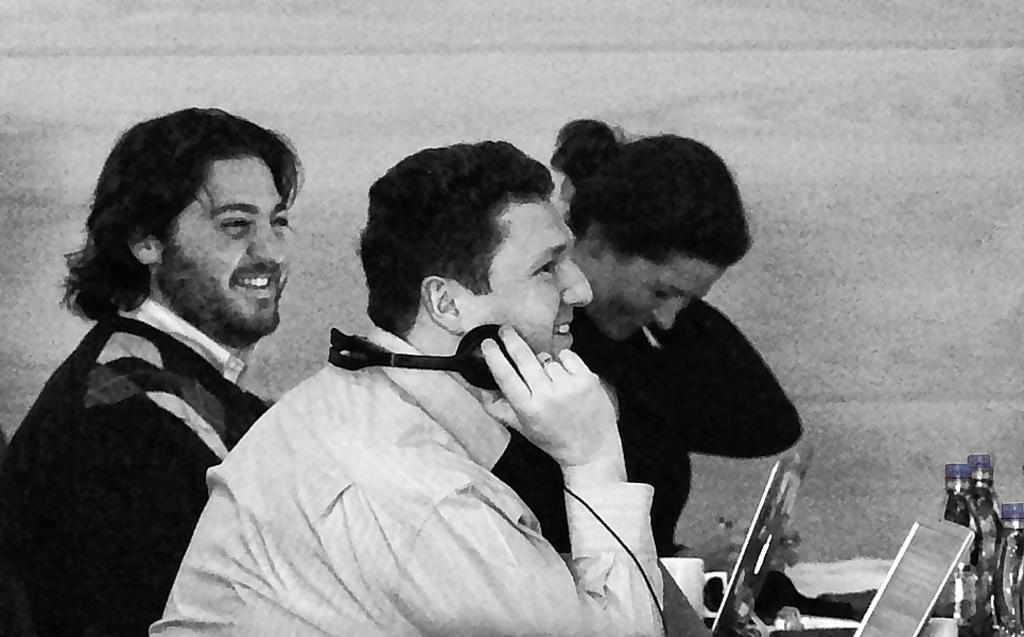Who or what is present in the image? There are people in the image. What is the facial expression of the people in the image? The people have smiles on their faces. What electronic devices can be seen in the image? There are laptops in the image. What items are present for hydration in the image? There are water bottles in the image. What type of haircut is being given to the person in the image? There is no haircut being given in the image; the people have smiles on their faces and are likely engaged in a different activity. What emotion is being expressed by the people in the image? The people in the image are expressing happiness, as they have smiles on their faces. 